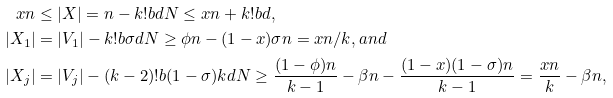Convert formula to latex. <formula><loc_0><loc_0><loc_500><loc_500>x n & \leq | X | = n - k ! b d N \leq x n + k ! b d , \\ | X _ { 1 } | & = | V _ { 1 } | - k ! b \sigma d N \geq \phi n - ( 1 - x ) \sigma n = x n / k , a n d \\ | X _ { j } | & = | V _ { j } | - ( k - 2 ) ! b ( 1 - \sigma ) k d N \geq \frac { ( 1 - \phi ) n } { k - 1 } - \beta n - \frac { ( 1 - x ) ( 1 - \sigma ) n } { k - 1 } = \frac { x n } { k } - \beta n ,</formula> 